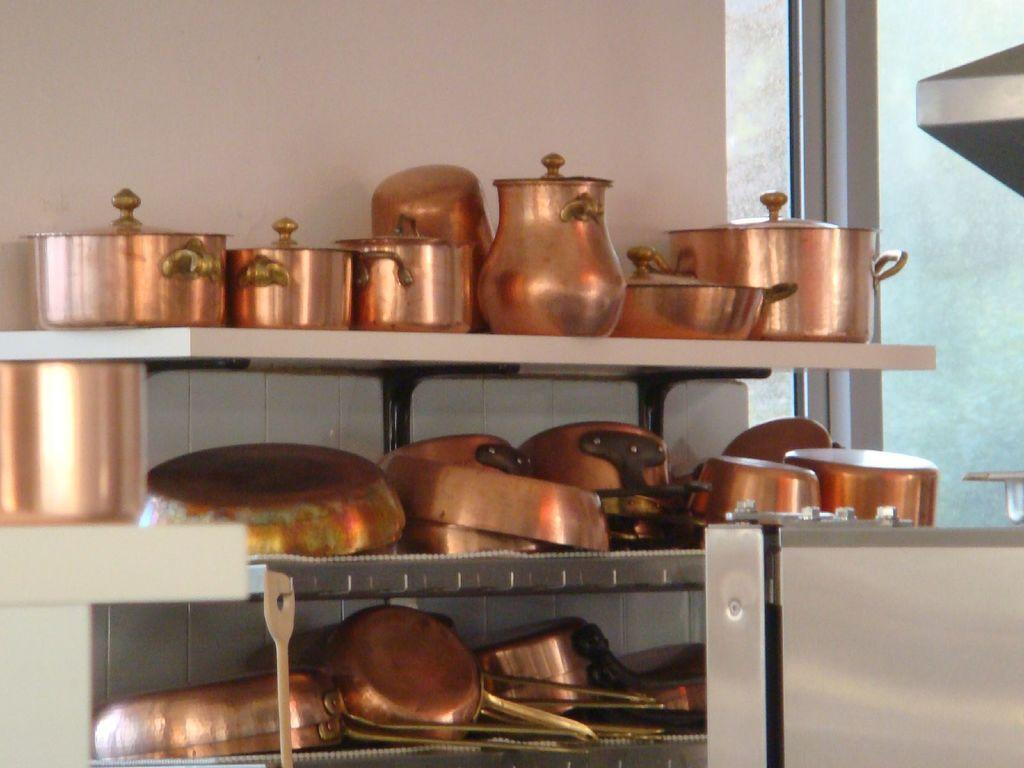What type of vessels are present in the image? There are copper vessels in the image. Who is present in the image? There are kids in the image. What can be seen in the background of the image? There is a wall and a window in the background of the image. What type of linen is being used by the company in the image? There is no mention of linen or a company in the image; it features copper vessels and kids. 